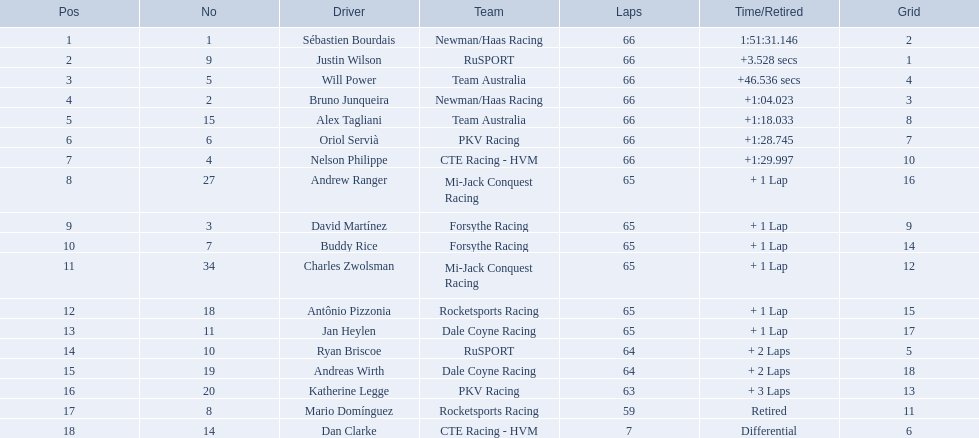Which people scored 29+ points? Sébastien Bourdais, Justin Wilson. Parse the table in full. {'header': ['Pos', 'No', 'Driver', 'Team', 'Laps', 'Time/Retired', 'Grid'], 'rows': [['1', '1', 'Sébastien Bourdais', 'Newman/Haas Racing', '66', '1:51:31.146', '2'], ['2', '9', 'Justin Wilson', 'RuSPORT', '66', '+3.528 secs', '1'], ['3', '5', 'Will Power', 'Team Australia', '66', '+46.536 secs', '4'], ['4', '2', 'Bruno Junqueira', 'Newman/Haas Racing', '66', '+1:04.023', '3'], ['5', '15', 'Alex Tagliani', 'Team Australia', '66', '+1:18.033', '8'], ['6', '6', 'Oriol Servià', 'PKV Racing', '66', '+1:28.745', '7'], ['7', '4', 'Nelson Philippe', 'CTE Racing - HVM', '66', '+1:29.997', '10'], ['8', '27', 'Andrew Ranger', 'Mi-Jack Conquest Racing', '65', '+ 1 Lap', '16'], ['9', '3', 'David Martínez', 'Forsythe Racing', '65', '+ 1 Lap', '9'], ['10', '7', 'Buddy Rice', 'Forsythe Racing', '65', '+ 1 Lap', '14'], ['11', '34', 'Charles Zwolsman', 'Mi-Jack Conquest Racing', '65', '+ 1 Lap', '12'], ['12', '18', 'Antônio Pizzonia', 'Rocketsports Racing', '65', '+ 1 Lap', '15'], ['13', '11', 'Jan Heylen', 'Dale Coyne Racing', '65', '+ 1 Lap', '17'], ['14', '10', 'Ryan Briscoe', 'RuSPORT', '64', '+ 2 Laps', '5'], ['15', '19', 'Andreas Wirth', 'Dale Coyne Racing', '64', '+ 2 Laps', '18'], ['16', '20', 'Katherine Legge', 'PKV Racing', '63', '+ 3 Laps', '13'], ['17', '8', 'Mario Domínguez', 'Rocketsports Racing', '59', 'Retired', '11'], ['18', '14', 'Dan Clarke', 'CTE Racing - HVM', '7', 'Differential', '6']]} Who scored higher? Sébastien Bourdais. 